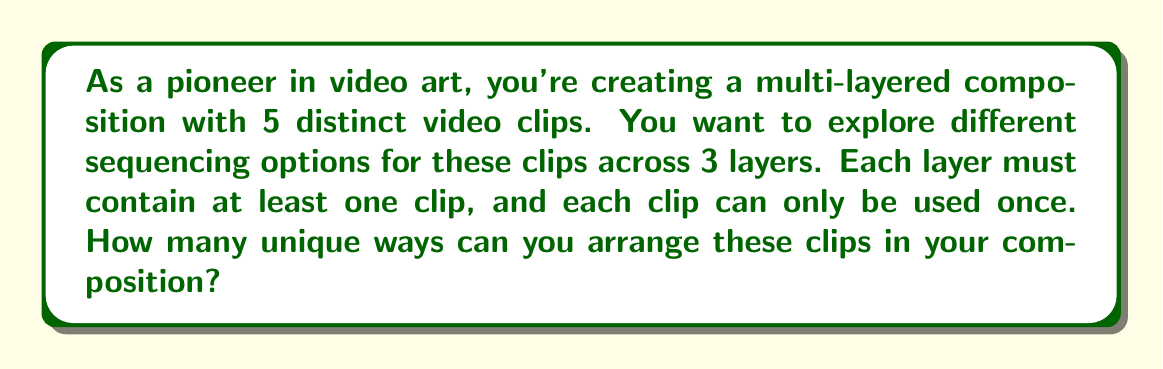Can you answer this question? Let's approach this step-by-step:

1) First, we need to distribute 5 clips across 3 layers. This is a partition problem.

2) The possible partitions of 5 clips into 3 layers are:
   3-1-1, 2-2-1

3) For the 3-1-1 partition:
   - Choose 3 clips for the first layer: $\binom{5}{3} = 10$ ways
   - Arrange these 3 clips: $3! = 6$ ways
   - Place the remaining 2 clips in 2 ways

   Total for 3-1-1: $10 \times 6 \times 2 = 120$ ways

4) For the 2-2-1 partition:
   - Choose 2 clips for the first layer: $\binom{5}{2} = 10$ ways
   - Choose 2 clips for the second layer: $\binom{3}{2} = 3$ ways
   - Arrange clips in each 2-clip layer: $2! \times 2! = 4$ ways
   - The last clip goes to the third layer

   Total for 2-2-1: $10 \times 3 \times 4 = 120$ ways

5) Sum up all possibilities: $120 + 120 = 240$

Therefore, there are 240 unique ways to arrange the clips in this composition.
Answer: 240 